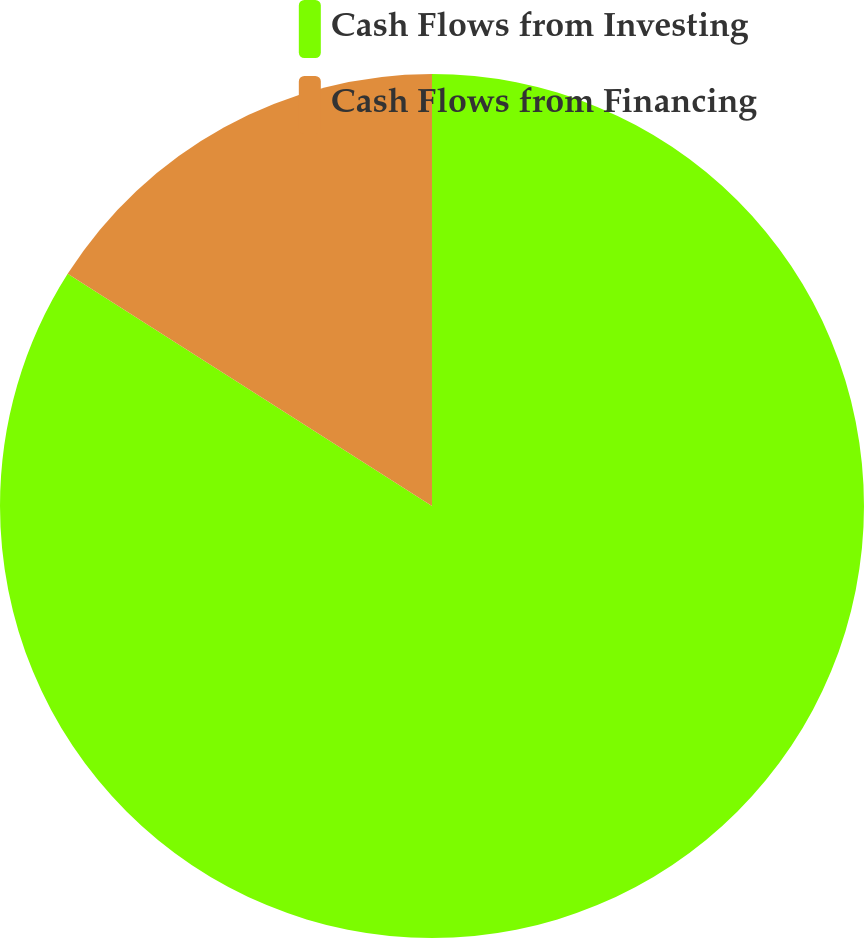<chart> <loc_0><loc_0><loc_500><loc_500><pie_chart><fcel>Cash Flows from Investing<fcel>Cash Flows from Financing<nl><fcel>84.03%<fcel>15.97%<nl></chart> 